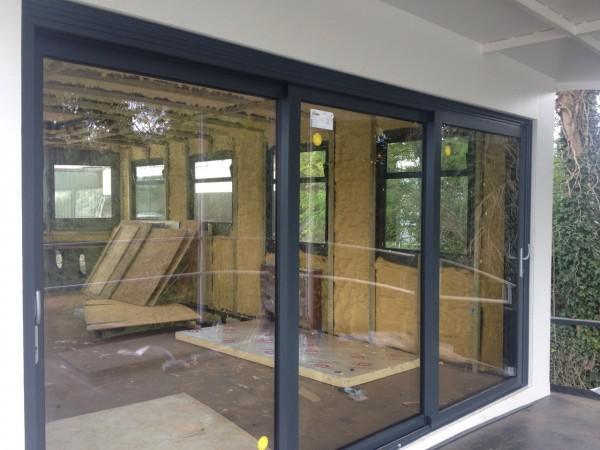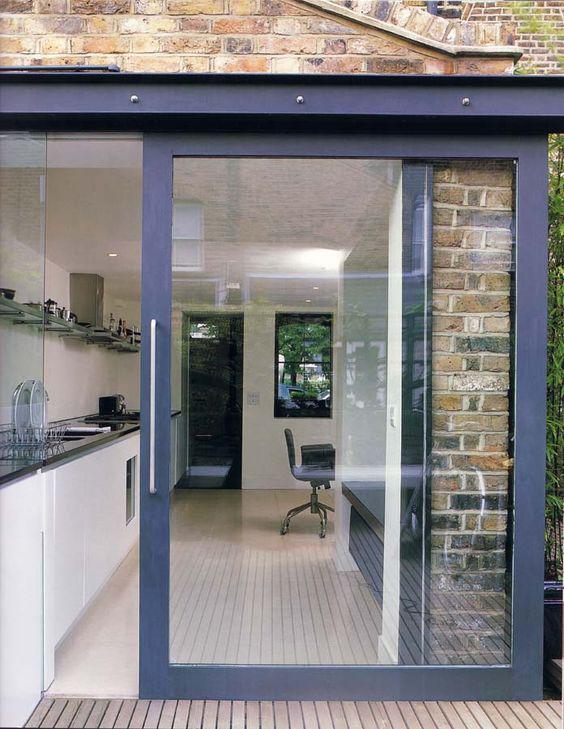The first image is the image on the left, the second image is the image on the right. Examine the images to the left and right. Is the description "There are four panes of glass in the sliding glass doors." accurate? Answer yes or no. No. 